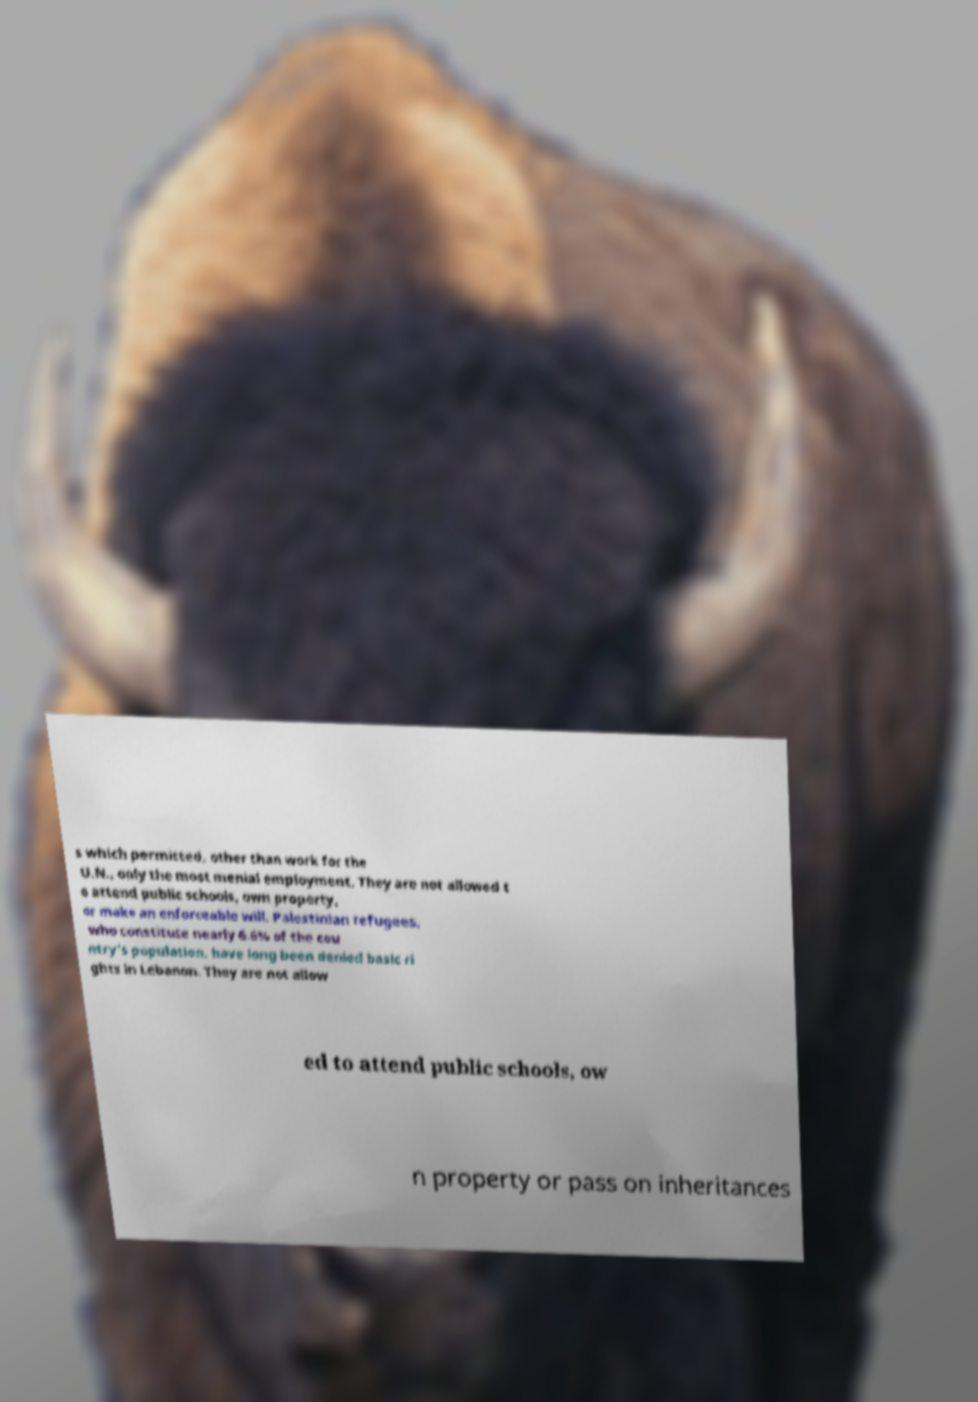Can you read and provide the text displayed in the image?This photo seems to have some interesting text. Can you extract and type it out for me? s which permitted, other than work for the U.N., only the most menial employment. They are not allowed t o attend public schools, own property, or make an enforceable will. Palestinian refugees, who constitute nearly 6.6% of the cou ntry's population, have long been denied basic ri ghts in Lebanon. They are not allow ed to attend public schools, ow n property or pass on inheritances 